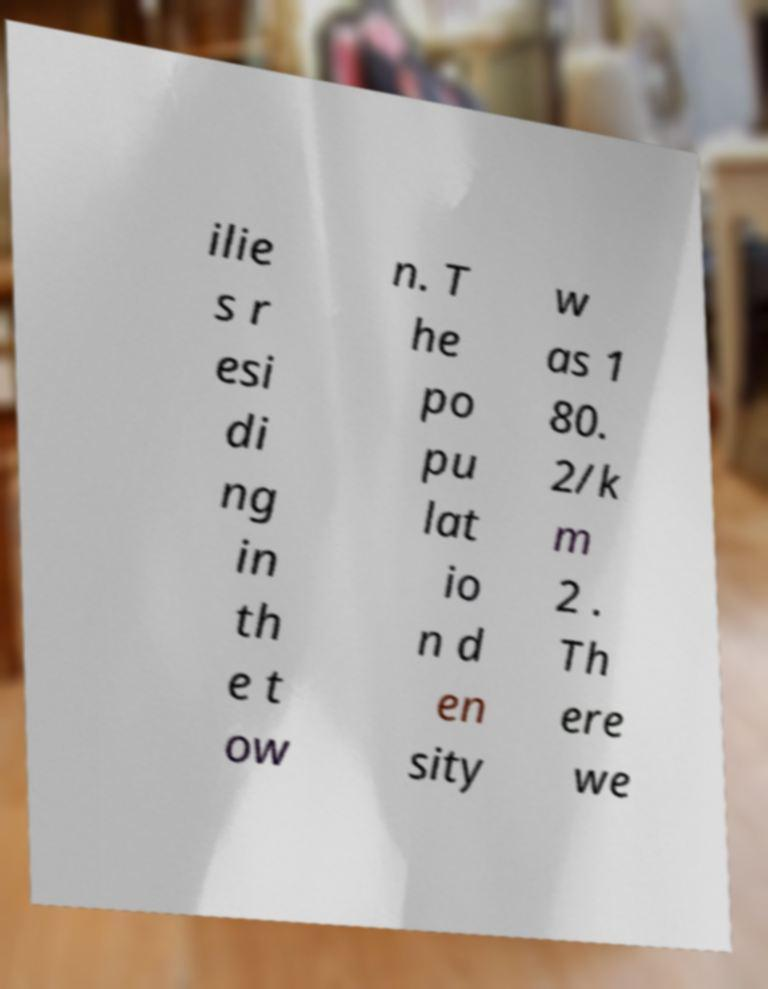Can you accurately transcribe the text from the provided image for me? ilie s r esi di ng in th e t ow n. T he po pu lat io n d en sity w as 1 80. 2/k m 2 . Th ere we 